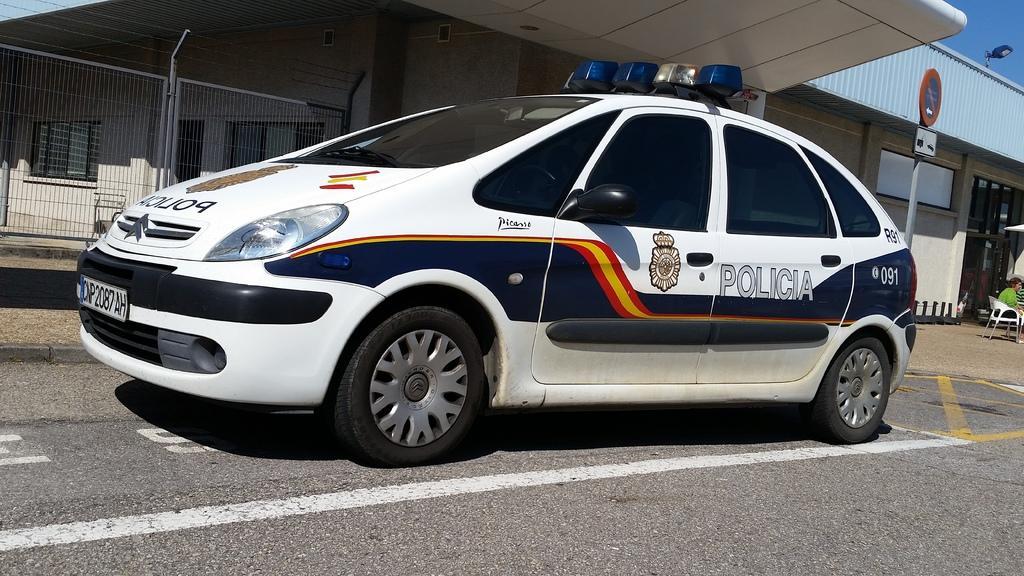Could you give a brief overview of what you see in this image? In the image in the center we can see one car on the road. In the background we can see sky,building,wall,sign board,fence,windows,one person sitting on the chair etc. 